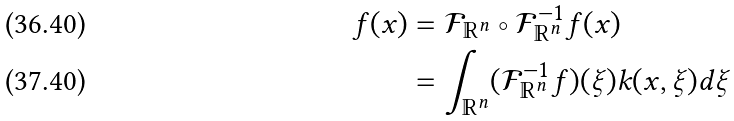<formula> <loc_0><loc_0><loc_500><loc_500>f ( x ) & = \mathcal { F } _ { \mathbb { R } ^ { n } } \circ \mathcal { F } _ { \mathbb { R } ^ { n } } ^ { - 1 } f ( x ) \\ & = \int _ { \mathbb { R } ^ { n } } ( \mathcal { F } _ { \mathbb { R } ^ { n } } ^ { - 1 } f ) ( \xi ) k ( x , \xi ) d \xi</formula> 